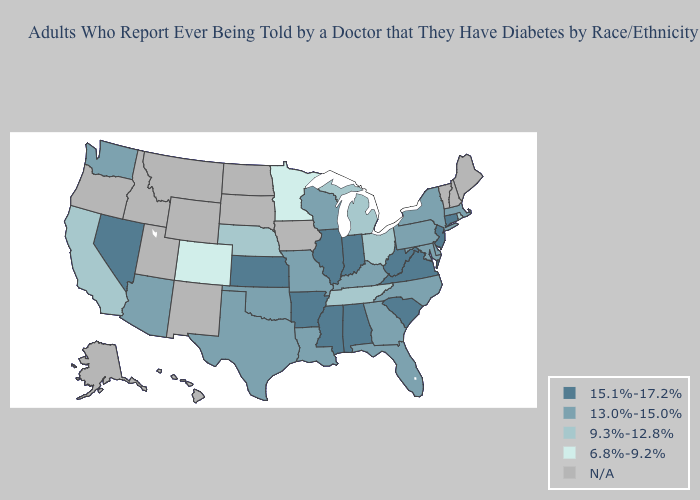Which states have the highest value in the USA?
Keep it brief. Alabama, Arkansas, Connecticut, Illinois, Indiana, Kansas, Mississippi, Nevada, New Jersey, South Carolina, Virginia, West Virginia. Does Delaware have the lowest value in the USA?
Short answer required. No. Name the states that have a value in the range 13.0%-15.0%?
Short answer required. Arizona, Delaware, Florida, Georgia, Kentucky, Louisiana, Maryland, Massachusetts, Missouri, New York, North Carolina, Oklahoma, Pennsylvania, Texas, Washington, Wisconsin. What is the lowest value in the MidWest?
Short answer required. 6.8%-9.2%. How many symbols are there in the legend?
Answer briefly. 5. What is the value of California?
Concise answer only. 9.3%-12.8%. Which states have the highest value in the USA?
Answer briefly. Alabama, Arkansas, Connecticut, Illinois, Indiana, Kansas, Mississippi, Nevada, New Jersey, South Carolina, Virginia, West Virginia. Does Tennessee have the lowest value in the USA?
Be succinct. No. Name the states that have a value in the range N/A?
Write a very short answer. Alaska, Hawaii, Idaho, Iowa, Maine, Montana, New Hampshire, New Mexico, North Dakota, Oregon, South Dakota, Utah, Vermont, Wyoming. Name the states that have a value in the range 15.1%-17.2%?
Quick response, please. Alabama, Arkansas, Connecticut, Illinois, Indiana, Kansas, Mississippi, Nevada, New Jersey, South Carolina, Virginia, West Virginia. Name the states that have a value in the range N/A?
Quick response, please. Alaska, Hawaii, Idaho, Iowa, Maine, Montana, New Hampshire, New Mexico, North Dakota, Oregon, South Dakota, Utah, Vermont, Wyoming. Which states have the lowest value in the USA?
Concise answer only. Colorado, Minnesota. Among the states that border Missouri , does Kansas have the highest value?
Give a very brief answer. Yes. What is the highest value in the Northeast ?
Quick response, please. 15.1%-17.2%. How many symbols are there in the legend?
Write a very short answer. 5. 